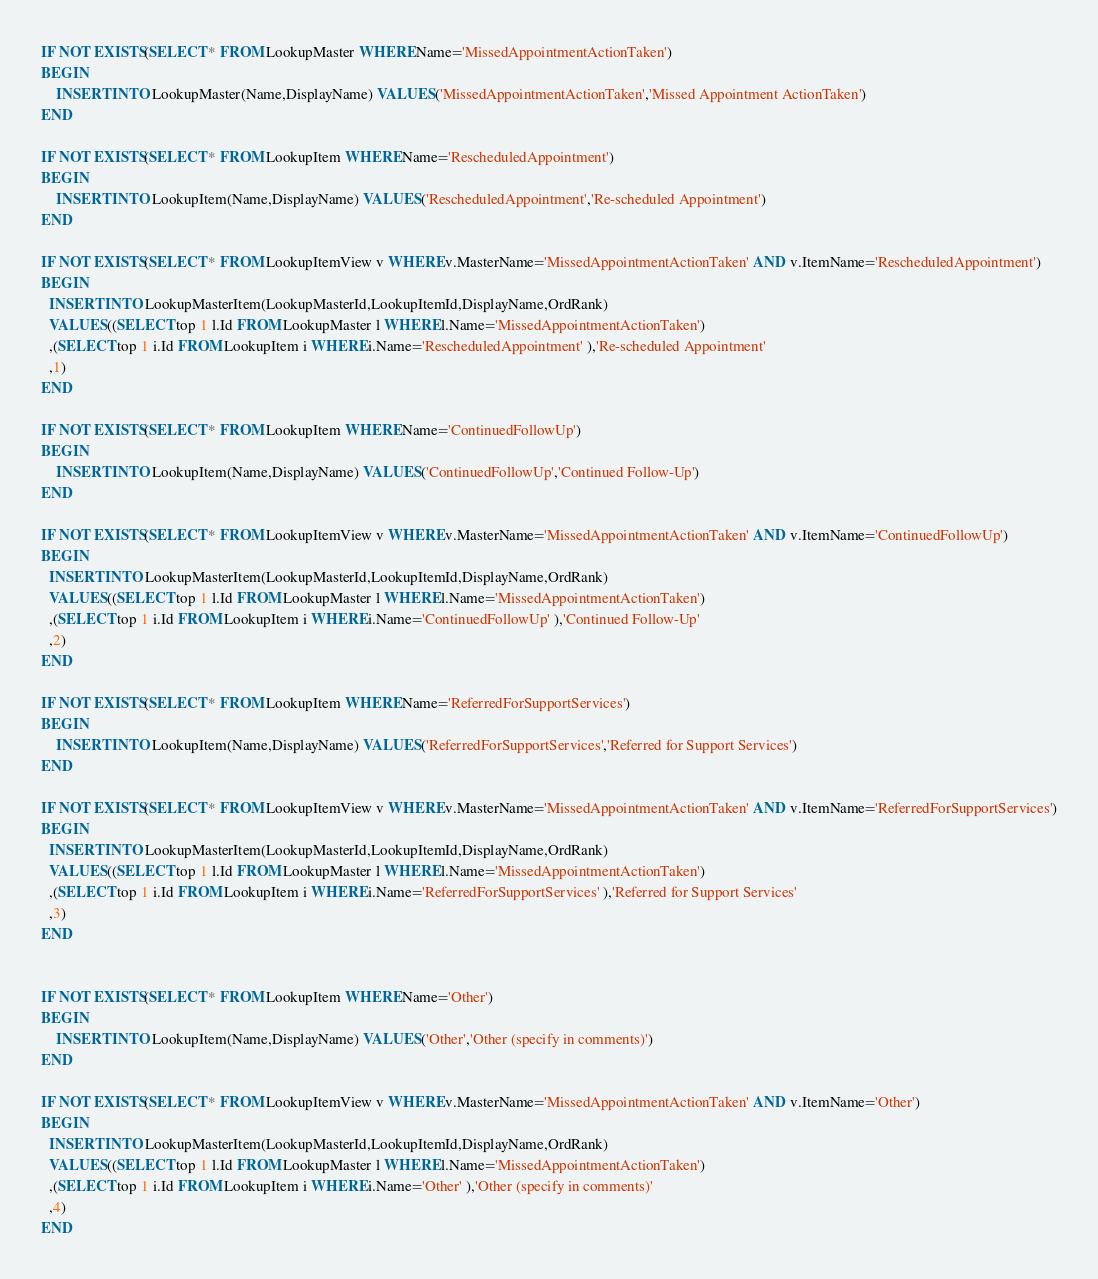Convert code to text. <code><loc_0><loc_0><loc_500><loc_500><_SQL_>IF NOT EXISTS(SELECT * FROM LookupMaster WHERE Name='MissedAppointmentActionTaken')
BEGIN 
	INSERT INTO LookupMaster(Name,DisplayName) VALUES('MissedAppointmentActionTaken','Missed Appointment ActionTaken')  
END

IF NOT EXISTS(SELECT * FROM LookupItem WHERE Name='RescheduledAppointment')
BEGIN 
	INSERT INTO LookupItem(Name,DisplayName) VALUES('RescheduledAppointment','Re-scheduled Appointment')  
END

IF NOT EXISTS(SELECT * FROM LookupItemView v WHERE v.MasterName='MissedAppointmentActionTaken' AND v.ItemName='RescheduledAppointment')
BEGIN
  INSERT INTO LookupMasterItem(LookupMasterId,LookupItemId,DisplayName,OrdRank) 
  VALUES((SELECT top 1 l.Id FROM LookupMaster l WHERE l.Name='MissedAppointmentActionTaken')
  ,(SELECT top 1 i.Id FROM LookupItem i WHERE i.Name='RescheduledAppointment' ),'Re-scheduled Appointment'
  ,1)
END

IF NOT EXISTS(SELECT * FROM LookupItem WHERE Name='ContinuedFollowUp')
BEGIN 
	INSERT INTO LookupItem(Name,DisplayName) VALUES('ContinuedFollowUp','Continued Follow-Up')  
END

IF NOT EXISTS(SELECT * FROM LookupItemView v WHERE v.MasterName='MissedAppointmentActionTaken' AND v.ItemName='ContinuedFollowUp')
BEGIN
  INSERT INTO LookupMasterItem(LookupMasterId,LookupItemId,DisplayName,OrdRank) 
  VALUES((SELECT top 1 l.Id FROM LookupMaster l WHERE l.Name='MissedAppointmentActionTaken')
  ,(SELECT top 1 i.Id FROM LookupItem i WHERE i.Name='ContinuedFollowUp' ),'Continued Follow-Up'
  ,2)
END

IF NOT EXISTS(SELECT * FROM LookupItem WHERE Name='ReferredForSupportServices')
BEGIN 
	INSERT INTO LookupItem(Name,DisplayName) VALUES('ReferredForSupportServices','Referred for Support Services')  
END

IF NOT EXISTS(SELECT * FROM LookupItemView v WHERE v.MasterName='MissedAppointmentActionTaken' AND v.ItemName='ReferredForSupportServices')
BEGIN
  INSERT INTO LookupMasterItem(LookupMasterId,LookupItemId,DisplayName,OrdRank) 
  VALUES((SELECT top 1 l.Id FROM LookupMaster l WHERE l.Name='MissedAppointmentActionTaken')
  ,(SELECT top 1 i.Id FROM LookupItem i WHERE i.Name='ReferredForSupportServices' ),'Referred for Support Services'
  ,3)
END


IF NOT EXISTS(SELECT * FROM LookupItem WHERE Name='Other')
BEGIN 
	INSERT INTO LookupItem(Name,DisplayName) VALUES('Other','Other (specify in comments)')  
END

IF NOT EXISTS(SELECT * FROM LookupItemView v WHERE v.MasterName='MissedAppointmentActionTaken' AND v.ItemName='Other')
BEGIN
  INSERT INTO LookupMasterItem(LookupMasterId,LookupItemId,DisplayName,OrdRank) 
  VALUES((SELECT top 1 l.Id FROM LookupMaster l WHERE l.Name='MissedAppointmentActionTaken')
  ,(SELECT top 1 i.Id FROM LookupItem i WHERE i.Name='Other' ),'Other (specify in comments)'
  ,4)
END


</code> 